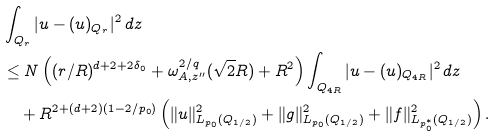<formula> <loc_0><loc_0><loc_500><loc_500>& \int _ { Q _ { r } } | u - ( u ) _ { Q _ { r } } | ^ { 2 } \, d z \\ & \leq N \left ( ( r / R ) ^ { d + 2 + 2 \delta _ { 0 } } + \omega _ { A , z ^ { \prime \prime } } ^ { 2 / q } ( \sqrt { 2 } R ) + R ^ { 2 } \right ) \int _ { Q _ { 4 R } } | u - ( u ) _ { Q _ { 4 R } } | ^ { 2 } \, d z \\ & \quad + R ^ { 2 + ( d + 2 ) ( 1 - 2 / p _ { 0 } ) } \left ( \| u \| ^ { 2 } _ { L _ { p _ { 0 } } ( Q _ { 1 / 2 } ) } + \| g \| ^ { 2 } _ { L _ { p _ { 0 } } ( Q _ { 1 / 2 } ) } + \| f \| ^ { 2 } _ { L _ { p ^ { * } _ { 0 } } ( Q _ { 1 / 2 } ) } \right ) .</formula> 